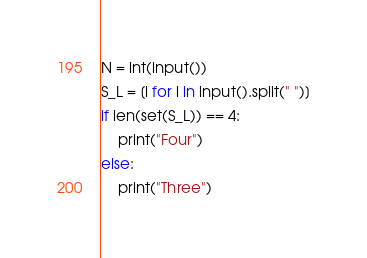<code> <loc_0><loc_0><loc_500><loc_500><_Python_>N = int(input())
S_L = [i for i in input().split(" ")]
if len(set(S_L)) == 4:
    print("Four")
else:
    print("Three")
</code> 